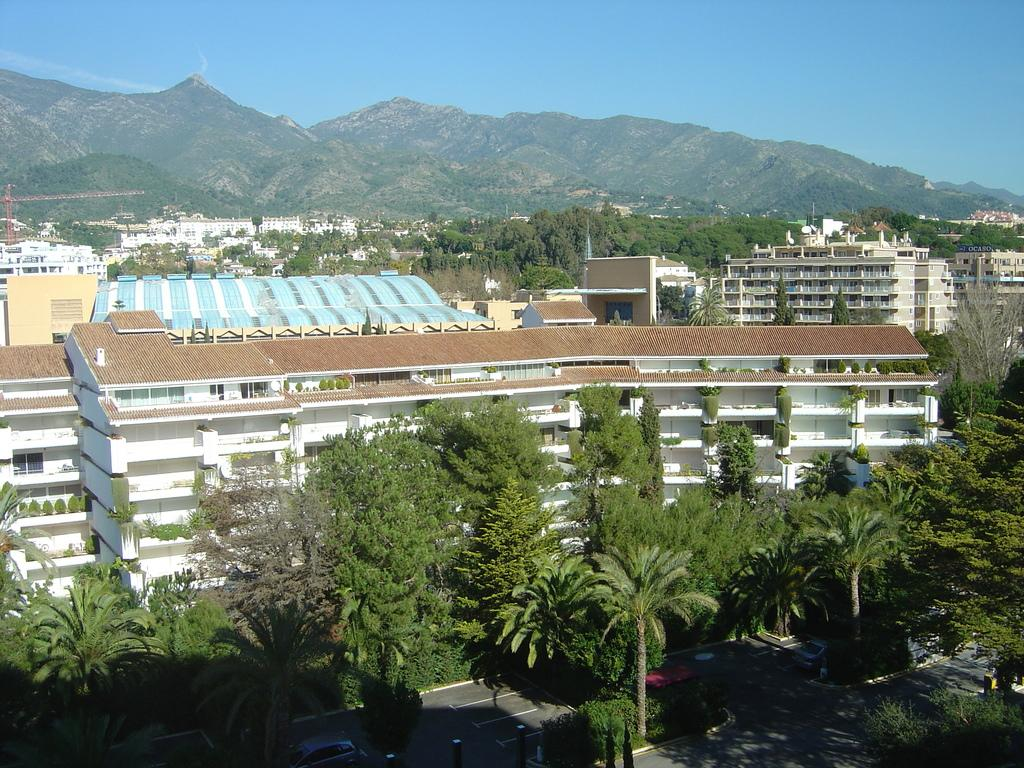What is the main subject in the center of the image? There are buildings in the center of the image. What type of natural elements can be seen in the image? There are trees in the image. What type of landscape feature is visible in the background? There are mountains in the background of the image. What is visible at the top of the image? The sky is visible at the top of the image. What is the income of the trees in the image? Trees do not have an income, as they are living organisms and not capable of earning money. 